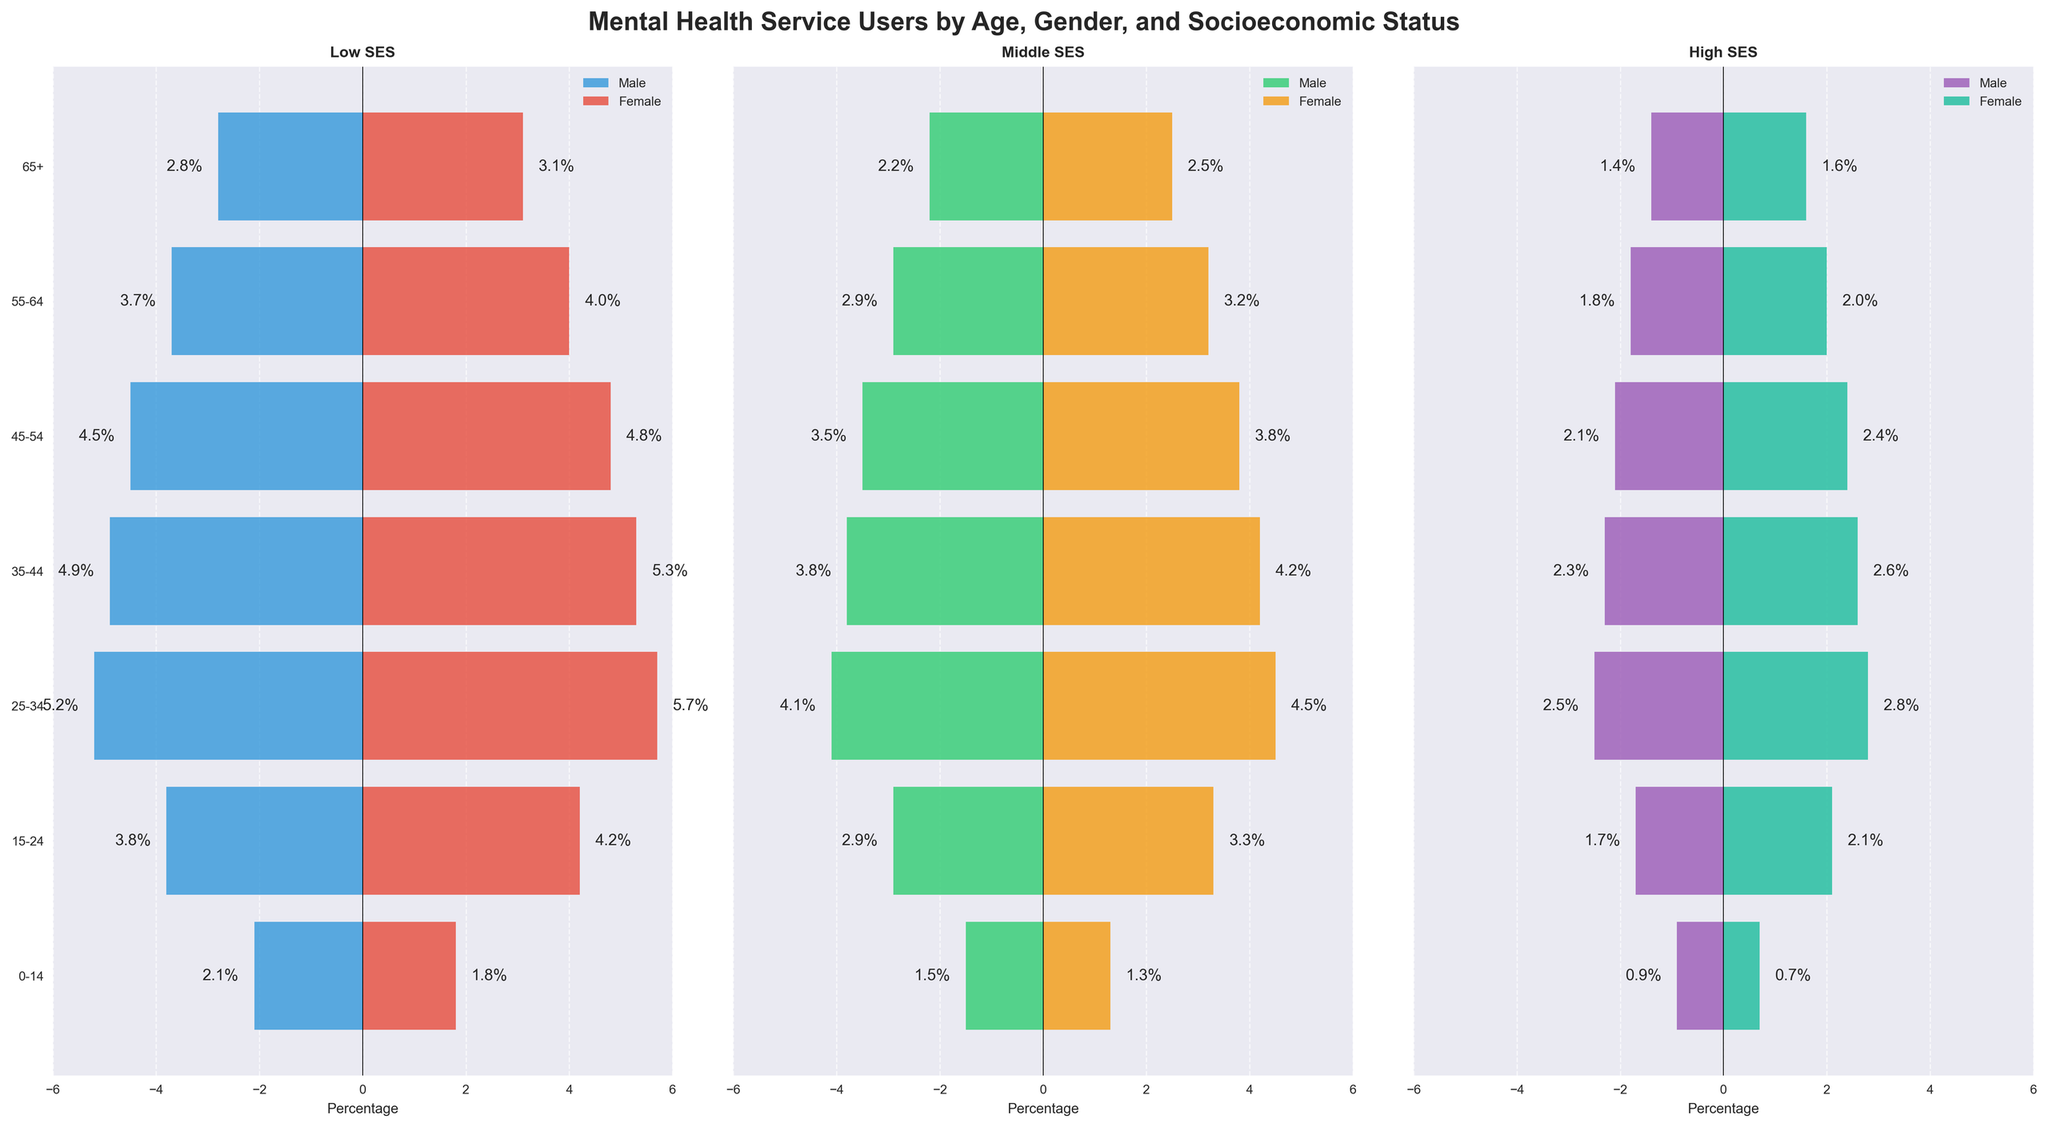Which age group has the highest percentage of male mental health service users in the low socioeconomic status (SES) group? To determine this, look at the "Male Low SES" bars on the left side of the "Low SES" pyramid. Identify which age group has the longest bar.
Answer: 25-34 How does the percentage of female mental health service users in the 15-24 age group compare between low and high socioeconomic status (SES)? Check the length of the "Female Low SES" bar for the 15-24 age group, and then compare it to the length of the "Female High SES" bar for the same age group in their respective pyramids.
Answer: Higher in Low SES What is the percentage difference in male mental health service users between the high and low socioeconomic status (SES) groups for the 35-44 age group? Find the "Male High SES" bar and the "Male Low SES" bar for the 35-44 age group in their respective pyramids. Calculate the difference, 4.9% (low) - 2.3% (high).
Answer: 2.6% Which age group shows the smallest disparity between male and female mental health service users in the middle socioeconomic status (SES) group? Look at the bars for "Male Middle SES" and "Female Middle SES" in each age group. Identify the group where the bars have the closest values.
Answer: 0-14 Is there a general pattern in terms of gender differences across all socioeconomic groups? Examine the bars for each gender across low, middle, and high SES groups to see if there is any consistent trend, such as females having consistently higher percentages or vice versa.
Answer: Females generally higher What's the total percentage of mental health service users aged 65+ in the middle socioeconomic status (SES) group? Add the "Male Middle SES" and "Female Middle SES" percentages for the 65+ age group: 2.2% (male) + 2.5% (female).
Answer: 4.7% In which age group do female mental health service users surpass their male counterparts by the largest margin within the low socioeconomic status (SES) group? Identify the age group with the largest visual difference between the "Female Low SES" bar and the "Male Low SES" bar.
Answer: 15-24 For the age group 55-64, how much higher is the percentage of female mental health service users in the low socioeconomic status (SES) compared to the high socioeconomic status (SES)? Compare the "Female Low SES" percentage with the "Female High SES" percentage for the 55-64 age group: 4.0% (low) - 2.0% (high).
Answer: 2.0% Which socioeconomic group has the lowest overall percentage of male mental health service users in the 25-34 age group? Compare the "Male Low SES," "Male Middle SES," and "Male High SES" bars for the 25-34 age group and identify the smallest value.
Answer: High SES 